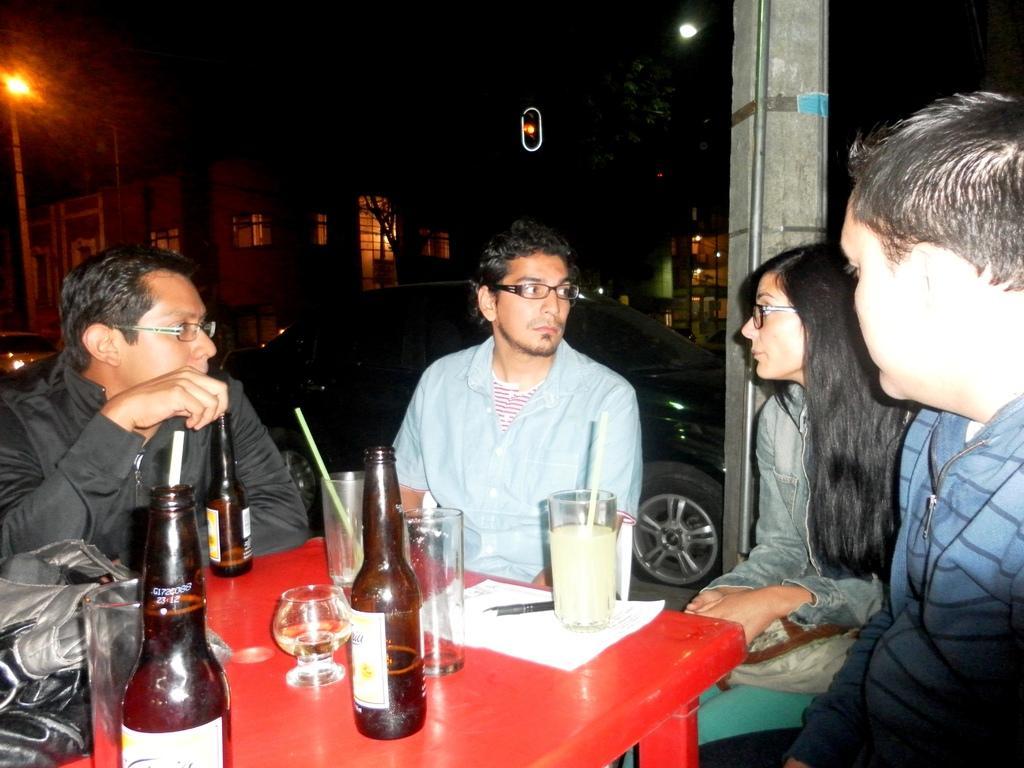Describe this image in one or two sentences. This picture shows three men and a woman seated and speaking to each other and we see few bottles and glasses on the table and we see a car parked back of them and we see few trees and a house 